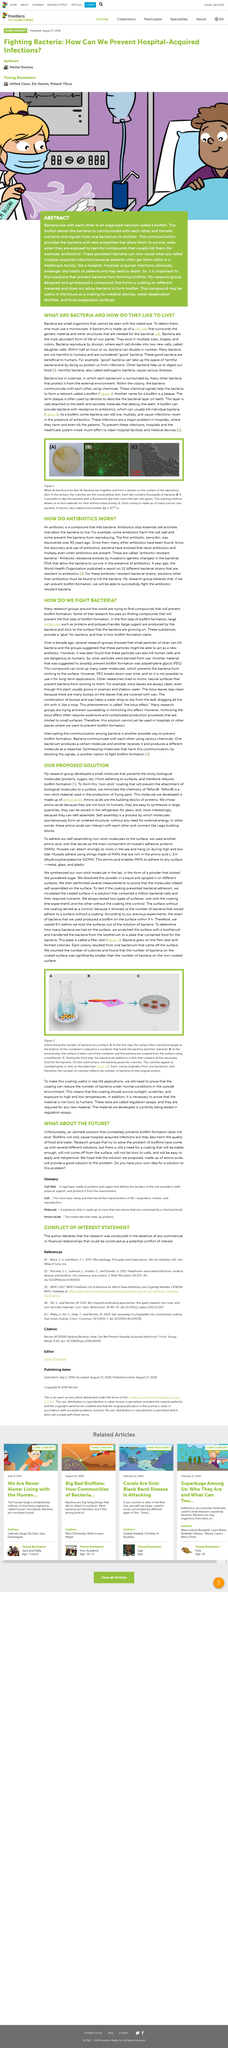Highlight a few significant elements in this photo. Despite the ongoing efforts to prevent biofilm formation, a definitive solution has yet to be discovered. The article describes small organisms that cannot be seen with the naked eye, which are bacteria. Biofilms are detrimental to health, causing hospital-acquired infections, and also impairing the quality of food and water. The article states that harmful bacteria are also known as pathogenic bacteria. According to the article, a microscope is necessary to detect bacteria. 